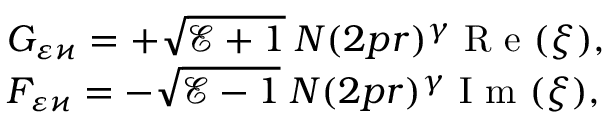<formula> <loc_0><loc_0><loc_500><loc_500>\begin{array} { l } { G _ { \varepsilon \varkappa } = + \sqrt { \mathcal { E } + 1 } \, N ( 2 p r ) ^ { \gamma } R e ( \xi ) , } \\ { F _ { \varepsilon \varkappa } = - \sqrt { \mathcal { E } - 1 } \, N ( 2 p r ) ^ { \gamma } I m ( \xi ) , } \end{array}</formula> 